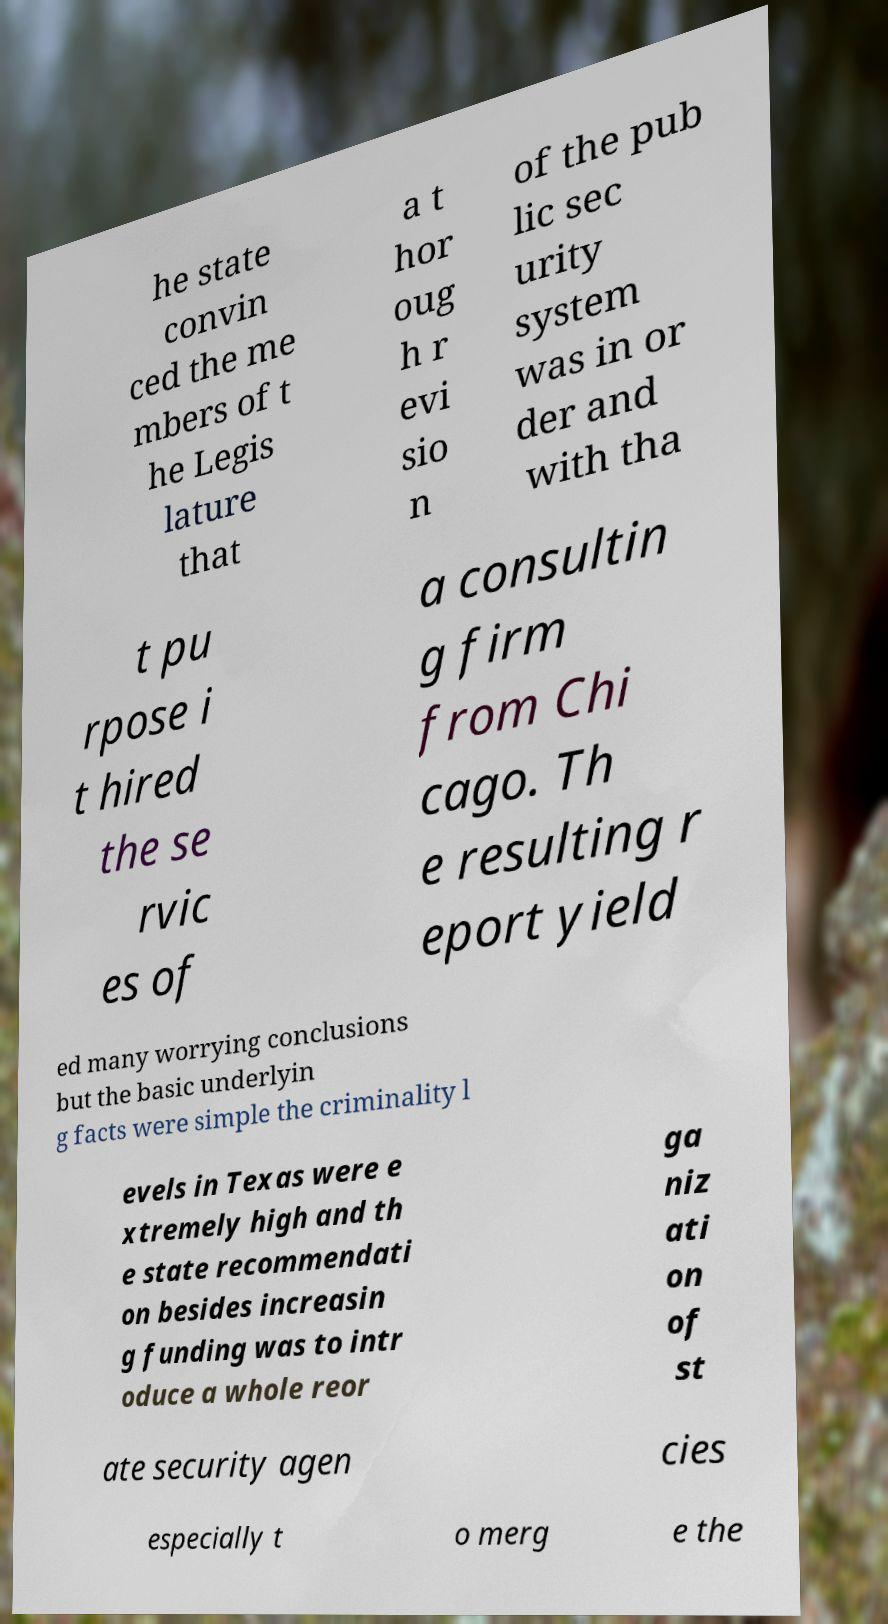Please read and relay the text visible in this image. What does it say? he state convin ced the me mbers of t he Legis lature that a t hor oug h r evi sio n of the pub lic sec urity system was in or der and with tha t pu rpose i t hired the se rvic es of a consultin g firm from Chi cago. Th e resulting r eport yield ed many worrying conclusions but the basic underlyin g facts were simple the criminality l evels in Texas were e xtremely high and th e state recommendati on besides increasin g funding was to intr oduce a whole reor ga niz ati on of st ate security agen cies especially t o merg e the 